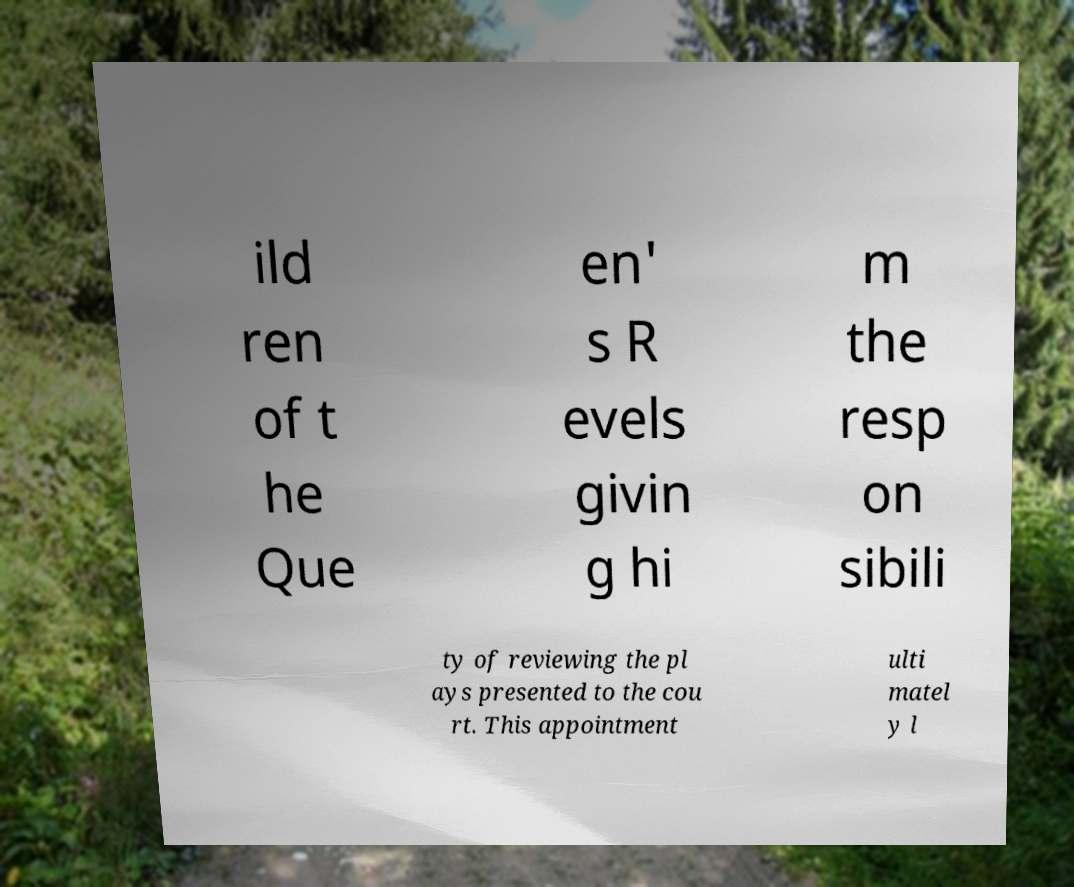Can you accurately transcribe the text from the provided image for me? ild ren of t he Que en' s R evels givin g hi m the resp on sibili ty of reviewing the pl ays presented to the cou rt. This appointment ulti matel y l 